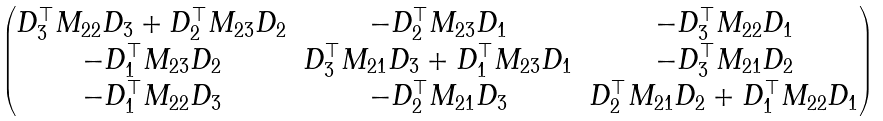Convert formula to latex. <formula><loc_0><loc_0><loc_500><loc_500>\begin{pmatrix} D _ { 3 } ^ { \top } M _ { 2 2 } D _ { 3 } + D _ { 2 } ^ { \top } M _ { 2 3 } D _ { 2 } & - D _ { 2 } ^ { \top } M _ { 2 3 } D _ { 1 } & - D _ { 3 } ^ { \top } M _ { 2 2 } D _ { 1 } \\ - D _ { 1 } ^ { \top } M _ { 2 3 } D _ { 2 } & D _ { 3 } ^ { \top } M _ { 2 1 } D _ { 3 } + D _ { 1 } ^ { \top } M _ { 2 3 } D _ { 1 } & - D _ { 3 } ^ { \top } M _ { 2 1 } D _ { 2 } \\ - D _ { 1 } ^ { \top } M _ { 2 2 } D _ { 3 } & - D _ { 2 } ^ { \top } M _ { 2 1 } D _ { 3 } & D _ { 2 } ^ { \top } M _ { 2 1 } D _ { 2 } + D _ { 1 } ^ { \top } M _ { 2 2 } D _ { 1 } \\ \end{pmatrix}</formula> 